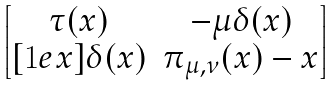Convert formula to latex. <formula><loc_0><loc_0><loc_500><loc_500>\begin{bmatrix} \tau ( x ) & - \mu \delta ( x ) \\ [ 1 e x ] \delta ( x ) & \pi _ { \mu , \nu } ( x ) - x \end{bmatrix}</formula> 